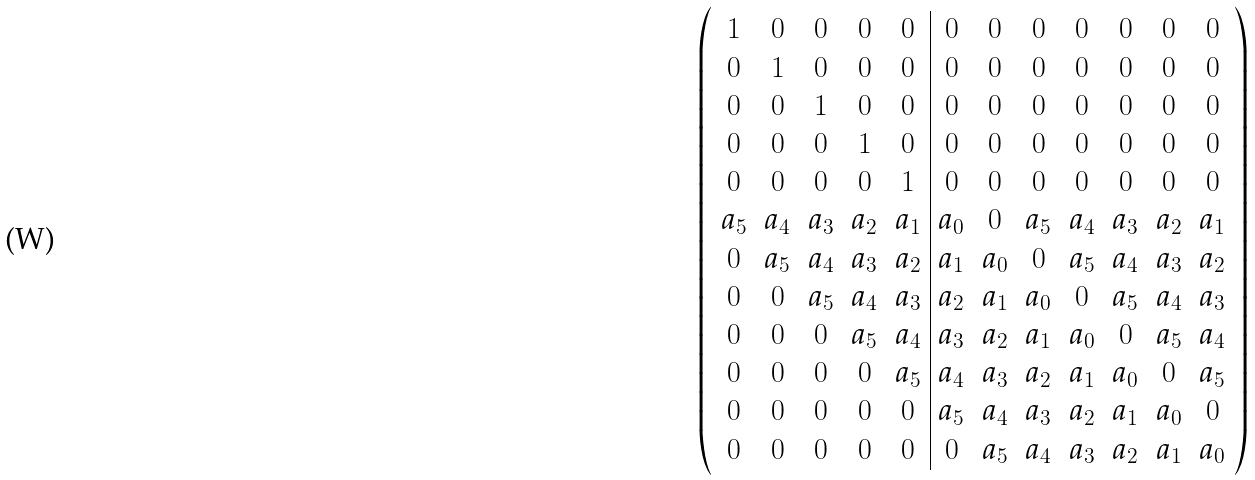Convert formula to latex. <formula><loc_0><loc_0><loc_500><loc_500>\left ( \begin{array} { c c c c c | c c c c c c c } 1 & 0 & 0 & 0 & 0 & 0 & 0 & 0 & 0 & 0 & 0 & 0 \\ 0 & 1 & 0 & 0 & 0 & 0 & 0 & 0 & 0 & 0 & 0 & 0 \\ 0 & 0 & 1 & 0 & 0 & 0 & 0 & 0 & 0 & 0 & 0 & 0 \\ 0 & 0 & 0 & 1 & 0 & 0 & 0 & 0 & 0 & 0 & 0 & 0 \\ 0 & 0 & 0 & 0 & 1 & 0 & 0 & 0 & 0 & 0 & 0 & 0 \\ a _ { 5 } & a _ { 4 } & a _ { 3 } & a _ { 2 } & a _ { 1 } & a _ { 0 } & 0 & a _ { 5 } & a _ { 4 } & a _ { 3 } & a _ { 2 } & a _ { 1 } \\ 0 & a _ { 5 } & a _ { 4 } & a _ { 3 } & a _ { 2 } & a _ { 1 } & a _ { 0 } & 0 & a _ { 5 } & a _ { 4 } & a _ { 3 } & a _ { 2 } \\ 0 & 0 & a _ { 5 } & a _ { 4 } & a _ { 3 } & a _ { 2 } & a _ { 1 } & a _ { 0 } & 0 & a _ { 5 } & a _ { 4 } & a _ { 3 } \\ 0 & 0 & 0 & a _ { 5 } & a _ { 4 } & a _ { 3 } & a _ { 2 } & a _ { 1 } & a _ { 0 } & 0 & a _ { 5 } & a _ { 4 } \\ 0 & 0 & 0 & 0 & a _ { 5 } & a _ { 4 } & a _ { 3 } & a _ { 2 } & a _ { 1 } & a _ { 0 } & 0 & a _ { 5 } \\ 0 & 0 & 0 & 0 & 0 & a _ { 5 } & a _ { 4 } & a _ { 3 } & a _ { 2 } & a _ { 1 } & a _ { 0 } & 0 \\ 0 & 0 & 0 & 0 & 0 & 0 & a _ { 5 } & a _ { 4 } & a _ { 3 } & a _ { 2 } & a _ { 1 } & a _ { 0 } \end{array} \right )</formula> 